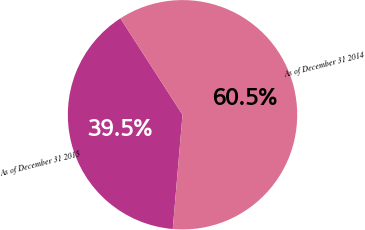Convert chart to OTSL. <chart><loc_0><loc_0><loc_500><loc_500><pie_chart><fcel>As of December 31 2015<fcel>As of December 31 2014<nl><fcel>39.53%<fcel>60.47%<nl></chart> 